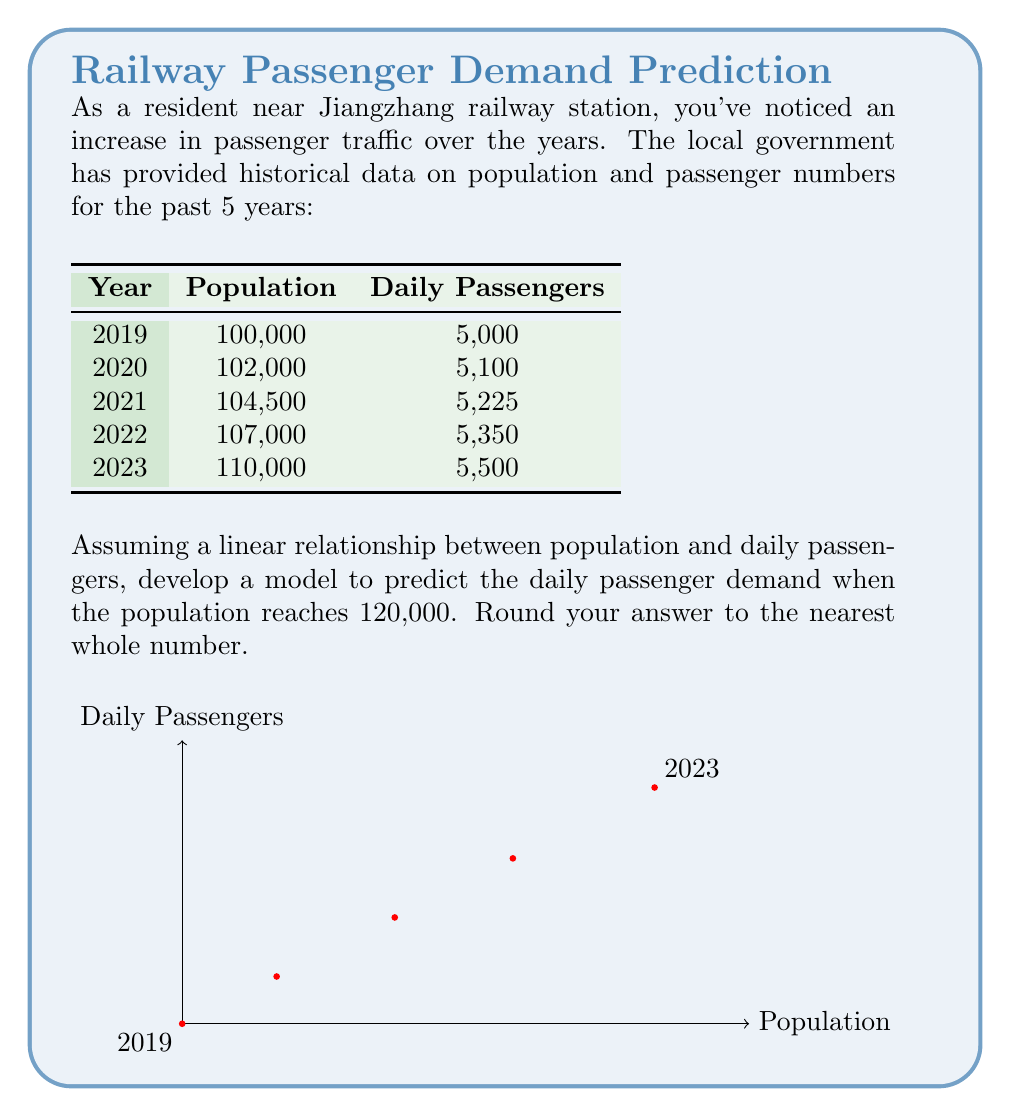Give your solution to this math problem. To develop a linear model predicting passenger demand based on population, we'll use the least squares method:

1) Calculate the means of population ($\bar{x}$) and daily passengers ($\bar{y}$):
   $$\bar{x} = \frac{100000 + 102000 + 104500 + 107000 + 110000}{5} = 104700$$
   $$\bar{y} = \frac{5000 + 5100 + 5225 + 5350 + 5500}{5} = 5235$$

2) Calculate the slope (m) using the formula:
   $$m = \frac{\sum(x_i - \bar{x})(y_i - \bar{y})}{\sum(x_i - \bar{x})^2}$$

   $$m = \frac{(-4700)(-235) + (-2700)(-135) + (-200)(-10) + (2300)(115) + (5300)(265)}{(-4700)^2 + (-2700)^2 + (-200)^2 + (2300)^2 + (5300)^2}$$
   
   $$m = \frac{2,762,500}{71,290,000} \approx 0.0387$$

3) Calculate the y-intercept (b) using $b = \bar{y} - m\bar{x}$:
   $$b = 5235 - (0.0387 \times 104700) \approx 1181.11$$

4) Our linear model is: $y = 0.0387x + 1181.11$

5) To predict daily passengers when population is 120,000:
   $$y = 0.0387(120000) + 1181.11 = 5825.11$$

6) Rounding to the nearest whole number: 5825
Answer: 5825 daily passengers 